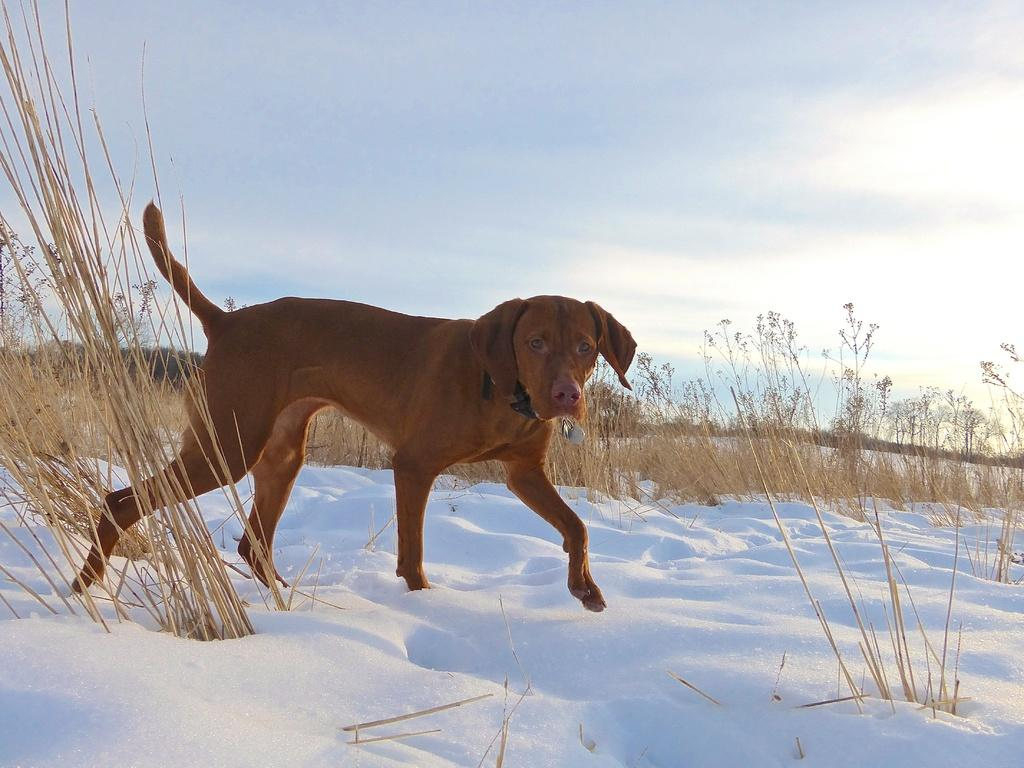What type of dog is in the image? There is a brown Labrador dog in the image. What is the dog doing in the image? The dog is walking on the snow. What type of vegetation is visible in the image? There is dry grass visible in the image. What is visible at the top of the image? The sky is visible at the top of the image. Who is the expert in the image? There is no expert present in the image; it features a brown Labrador dog walking on the snow. How many trees are visible in the image? There are no trees visible in the image; it features a brown Labrador dog walking on the snow with dry grass and a visible sky. 